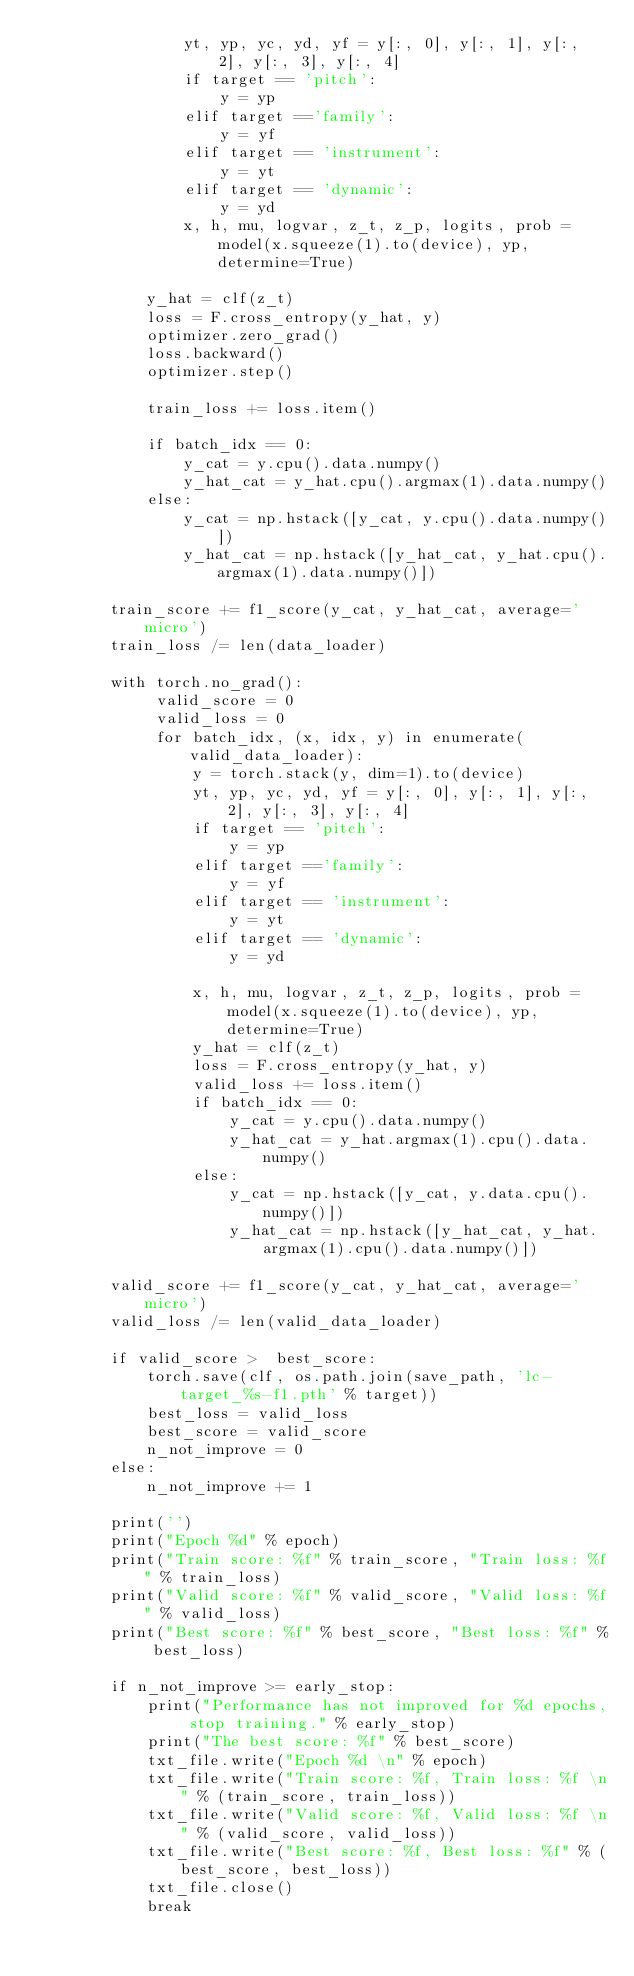Convert code to text. <code><loc_0><loc_0><loc_500><loc_500><_Python_>                yt, yp, yc, yd, yf = y[:, 0], y[:, 1], y[:, 2], y[:, 3], y[:, 4]
                if target == 'pitch':
                    y = yp
                elif target =='family':
                    y = yf
                elif target == 'instrument':
                    y = yt
                elif target == 'dynamic':
                    y = yd
                x, h, mu, logvar, z_t, z_p, logits, prob = model(x.squeeze(1).to(device), yp, determine=True)

            y_hat = clf(z_t)
            loss = F.cross_entropy(y_hat, y)
            optimizer.zero_grad()
            loss.backward()
            optimizer.step()

            train_loss += loss.item()

            if batch_idx == 0:
                y_cat = y.cpu().data.numpy()
                y_hat_cat = y_hat.cpu().argmax(1).data.numpy()
            else:
                y_cat = np.hstack([y_cat, y.cpu().data.numpy()])
                y_hat_cat = np.hstack([y_hat_cat, y_hat.cpu().argmax(1).data.numpy()])           

        train_score += f1_score(y_cat, y_hat_cat, average='micro')
        train_loss /= len(data_loader)

        with torch.no_grad():
             valid_score = 0  
             valid_loss = 0
             for batch_idx, (x, idx, y) in enumerate(valid_data_loader):
                 y = torch.stack(y, dim=1).to(device)
                 yt, yp, yc, yd, yf = y[:, 0], y[:, 1], y[:, 2], y[:, 3], y[:, 4]
                 if target == 'pitch':
                     y = yp
                 elif target =='family':
                     y = yf
                 elif target == 'instrument':
                     y = yt
                 elif target == 'dynamic':
                     y = yd
                 
                 x, h, mu, logvar, z_t, z_p, logits, prob = model(x.squeeze(1).to(device), yp, determine=True)
                 y_hat = clf(z_t)
                 loss = F.cross_entropy(y_hat, y)
                 valid_loss += loss.item()
                 if batch_idx == 0:
                     y_cat = y.cpu().data.numpy()
                     y_hat_cat = y_hat.argmax(1).cpu().data.numpy()
                 else:
                     y_cat = np.hstack([y_cat, y.data.cpu().numpy()])
                     y_hat_cat = np.hstack([y_hat_cat, y_hat.argmax(1).cpu().data.numpy()])           

        valid_score += f1_score(y_cat, y_hat_cat, average='micro')
        valid_loss /= len(valid_data_loader)

        if valid_score >  best_score:
            torch.save(clf, os.path.join(save_path, 'lc-target_%s-f1.pth' % target))
            best_loss = valid_loss
            best_score = valid_score
            n_not_improve = 0
        else:
            n_not_improve += 1

        print('')
        print("Epoch %d" % epoch)
        print("Train score: %f" % train_score, "Train loss: %f" % train_loss)
        print("Valid score: %f" % valid_score, "Valid loss: %f" % valid_loss)
        print("Best score: %f" % best_score, "Best loss: %f" % best_loss)

        if n_not_improve >= early_stop:
            print("Performance has not improved for %d epochs, stop training." % early_stop)
            print("The best score: %f" % best_score)
            txt_file.write("Epoch %d \n" % epoch)
            txt_file.write("Train score: %f, Train loss: %f \n" % (train_score, train_loss))
            txt_file.write("Valid score: %f, Valid loss: %f \n" % (valid_score, valid_loss))
            txt_file.write("Best score: %f, Best loss: %f" % (best_score, best_loss))
            txt_file.close()
            break
</code> 